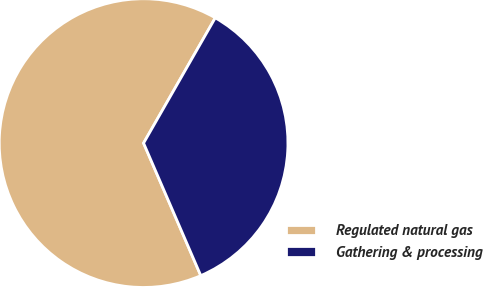Convert chart to OTSL. <chart><loc_0><loc_0><loc_500><loc_500><pie_chart><fcel>Regulated natural gas<fcel>Gathering & processing<nl><fcel>64.76%<fcel>35.24%<nl></chart> 